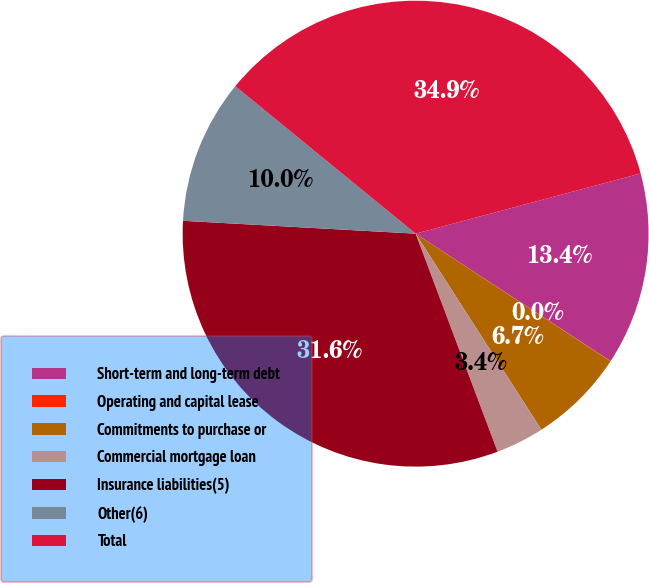Convert chart. <chart><loc_0><loc_0><loc_500><loc_500><pie_chart><fcel>Short-term and long-term debt<fcel>Operating and capital lease<fcel>Commitments to purchase or<fcel>Commercial mortgage loan<fcel>Insurance liabilities(5)<fcel>Other(6)<fcel>Total<nl><fcel>13.37%<fcel>0.02%<fcel>6.69%<fcel>3.36%<fcel>31.6%<fcel>10.03%<fcel>34.93%<nl></chart> 